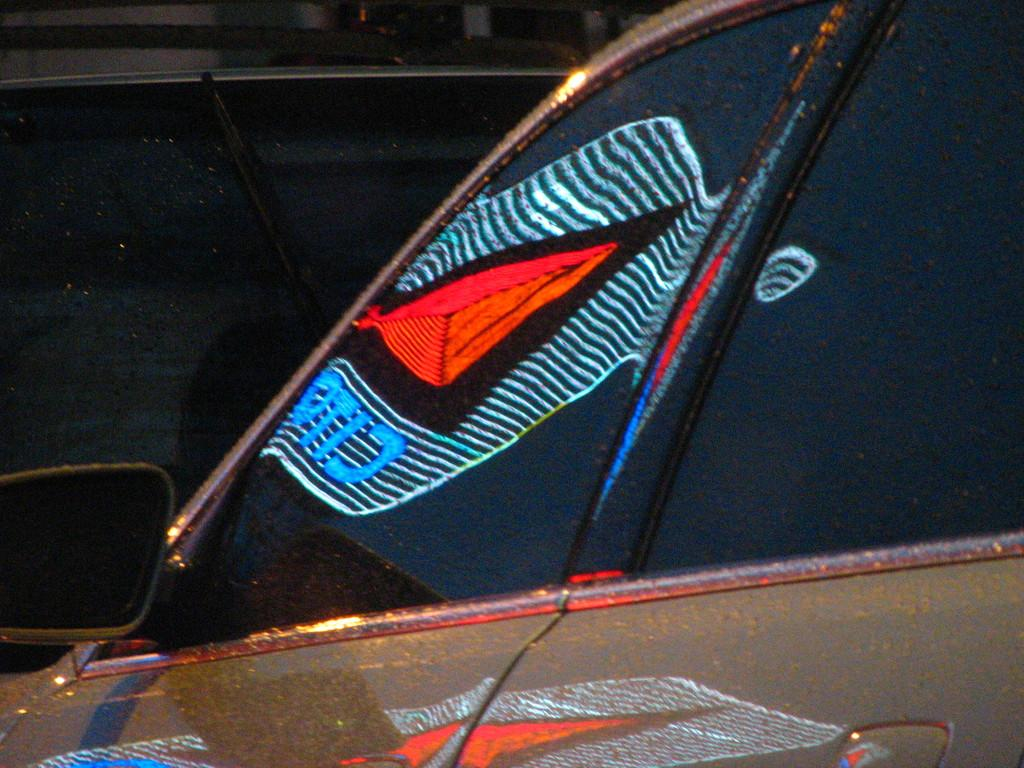What type of vehicles can be seen in the image? There are cars in the image. Can you describe the setting where the cars are located? The image does not provide enough information to describe the setting. How many cars are visible in the image? The number of cars cannot be determined from the provided facts. What type of dinosaurs can be seen interacting with the cars in the image? There are no dinosaurs present in the image; it features cars only. 